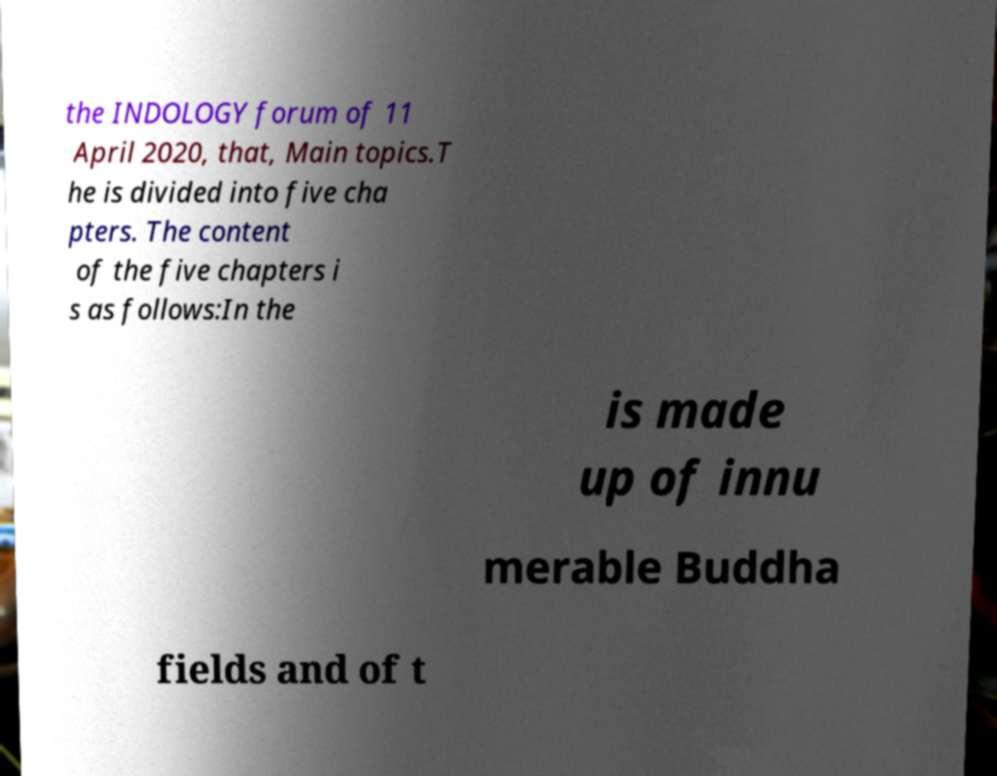Could you extract and type out the text from this image? the INDOLOGY forum of 11 April 2020, that, Main topics.T he is divided into five cha pters. The content of the five chapters i s as follows:In the is made up of innu merable Buddha fields and of t 